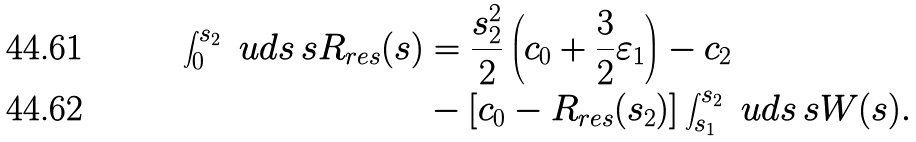Convert formula to latex. <formula><loc_0><loc_0><loc_500><loc_500>\int ^ { s _ { 2 } } _ { 0 } \ u d s \, s R _ { r e s } ( s ) & = \frac { s ^ { 2 } _ { 2 } } { 2 } \left ( c _ { 0 } + \frac { 3 } { 2 } \varepsilon _ { 1 } \right ) - c _ { 2 } \\ & - \left [ c _ { 0 } - R _ { r e s } ( s _ { 2 } ) \right ] \int ^ { s _ { 2 } } _ { s _ { 1 } } \ u d s \, s W ( s ) .</formula> 